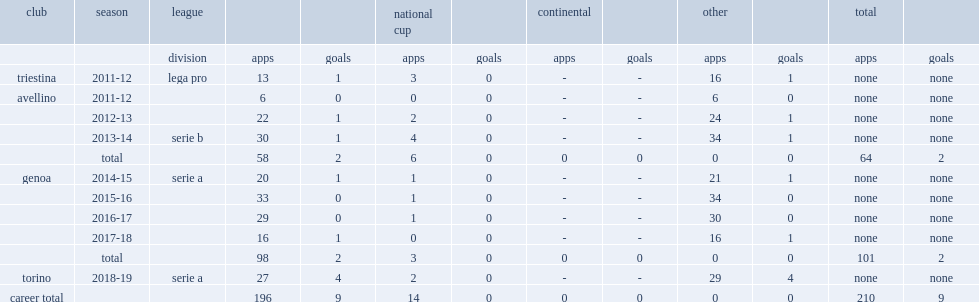How many goals did izzo score for avellino in the 2013-14 season? 1.0. 